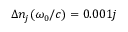<formula> <loc_0><loc_0><loc_500><loc_500>\Delta n _ { j } ( \omega _ { 0 } / c ) = 0 . 0 0 1 j</formula> 